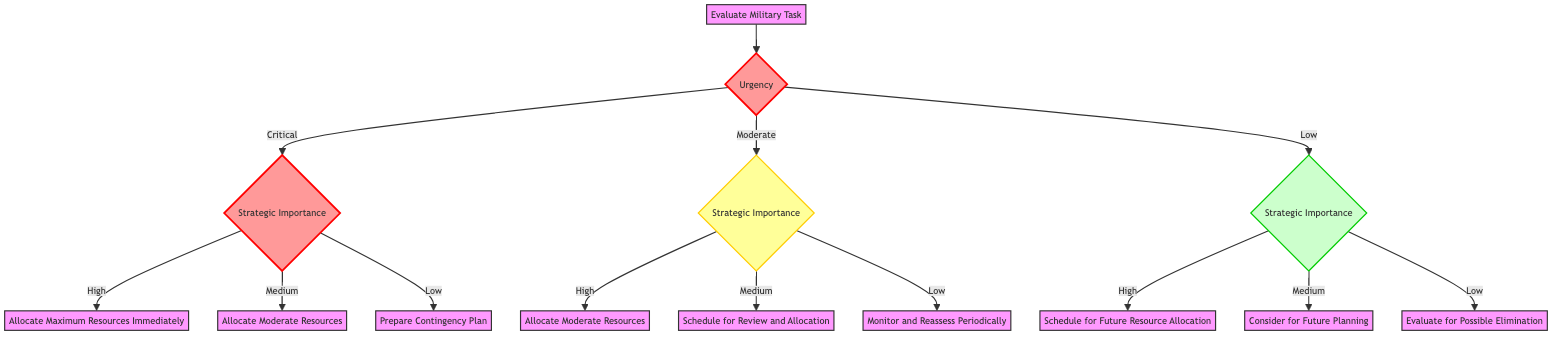What is the first decision point in the diagram? The diagram starts with "Urgency" as the first decision point, which branches into three categories: Critical, Moderate, and Low.
Answer: Urgency How many possible outcomes are there for 'Critical' urgency? For 'Critical' urgency, there are three outcomes based on strategic importance: High, Medium, and Low. Each outcome leads to a specific action.
Answer: Three What action is taken when urgency is 'Low' and strategic importance is 'Medium'? When urgency is 'Low' and strategic importance is 'Medium', the action is to "Consider for Future Planning".
Answer: Consider for Future Planning Which actions are associated with 'Moderate' urgency and 'Low' strategic importance? The action for 'Moderate' urgency and 'Low' strategic importance is "Monitor and Reassess Periodically".
Answer: Monitor and Reassess Periodically What is the relationship between 'Critical' urgency and 'High' strategic importance? For a 'Critical' urgency, if the strategic importance is 'High', the action taken is to "Allocate Maximum Resources Immediately", indicating a direct relation of urgency demanding full resource allocation.
Answer: Allocate Maximum Resources Immediately If a task is 'Moderate' urgency and 'High' strategic importance, what action is taken? For 'Moderate' urgency together with 'High' strategic importance, the action is to "Allocate Moderate Resources". This indicates that while the urgency is not the highest, the strategic importance requires assigning resources nevertheless.
Answer: Allocate Moderate Resources What kind of tasks fall under 'Low' urgency and 'High' strategic importance? Under 'Low' urgency and 'High' strategic importance, tasks like "Long-Term Infrastructure Development" and "Strategic Logistics Planning" are examples of actions to be scheduled for future resource allocation.
Answer: Long-Term Infrastructure Development, Strategic Logistics Planning What is the total number of unique actions listed in the diagram? Each urgency level combined with strategic importance yields a unique action. Therefore, adding them up from each category (Critical, Moderate, Low) provides a total of 9 unique actions.
Answer: Nine How are the branches structured after the 'Urgency' decision point? After the 'Urgency' decision point, the branches break into three outcomes (Critical, Moderate, Low), each leading to another decision point based on 'Strategic Importance', resulting in further actions.
Answer: Into three outcomes 